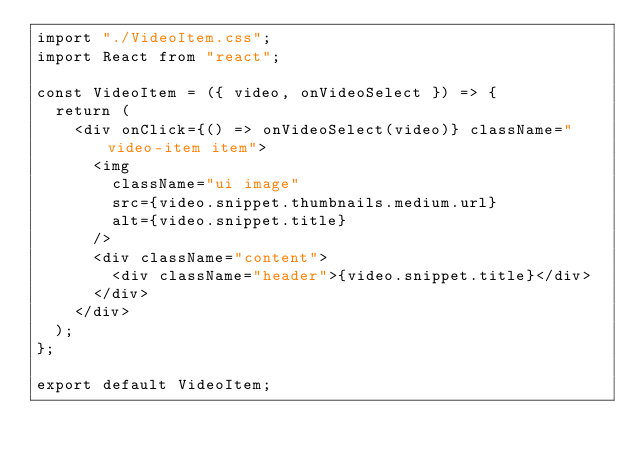<code> <loc_0><loc_0><loc_500><loc_500><_JavaScript_>import "./VideoItem.css";
import React from "react";

const VideoItem = ({ video, onVideoSelect }) => {
  return (
    <div onClick={() => onVideoSelect(video)} className="video-item item">
      <img
        className="ui image"
        src={video.snippet.thumbnails.medium.url}
        alt={video.snippet.title}
      />
      <div className="content">
        <div className="header">{video.snippet.title}</div>
      </div>
    </div>
  );
};

export default VideoItem;
</code> 